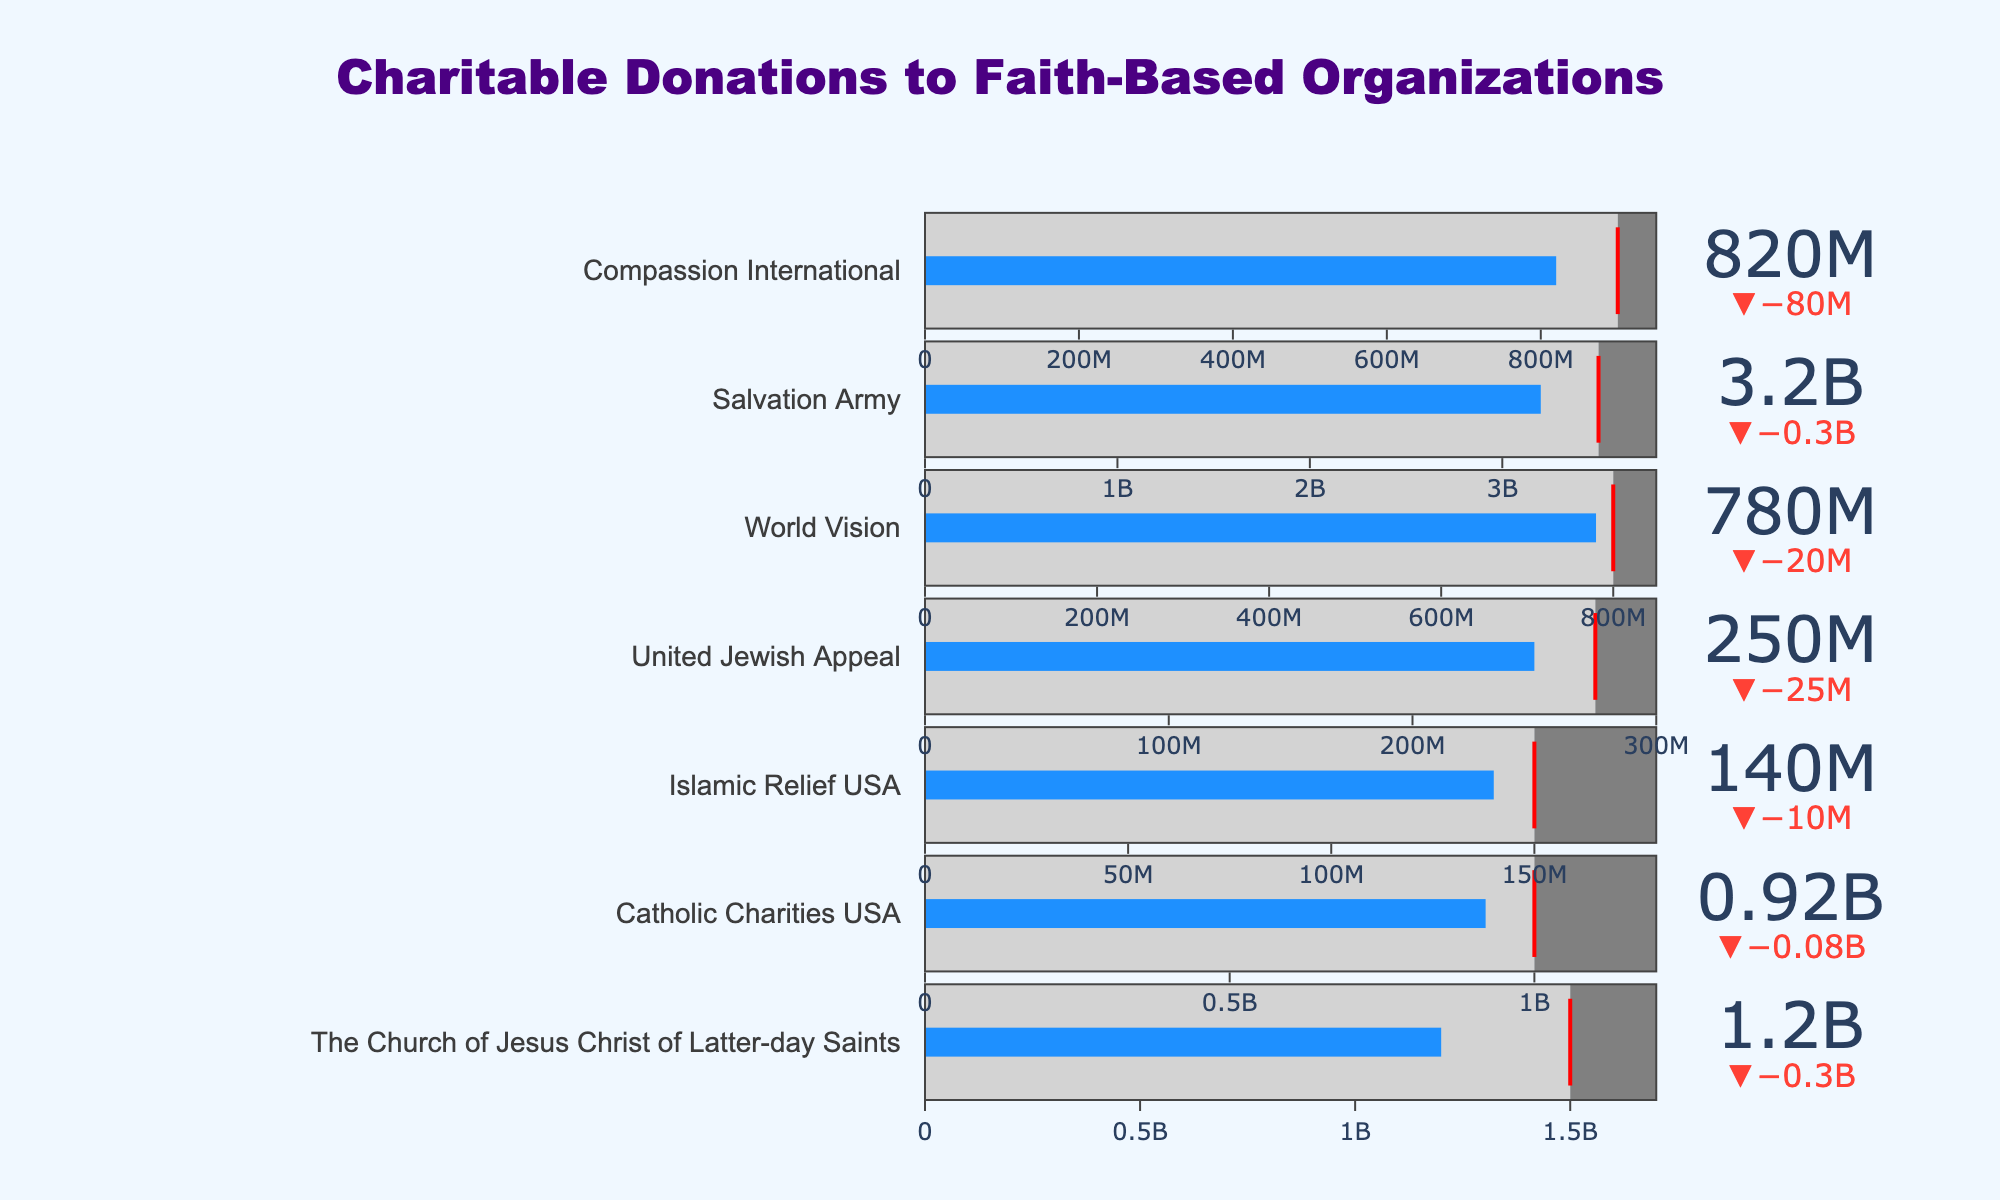What is the highest target donation value among all organizations? Look at the 'Target' values. The Salvation Army has the highest target donation value of 3500000000.
Answer: 3500000000 Which organization received the lowest actual donations? Compare the 'Actual Donations' values. Islamic Relief USA has the lowest actual donations of 140000000.
Answer: Islamic Relief USA How much more did Catholic Charities USA need to meet its target? Subtract the 'Actual Donations' from the 'Target' for Catholic Charities USA: 1000000000 - 920000000 = 80000000.
Answer: 80000000 Which organization exceeded its target by the largest amount? Calculate the difference between 'Actual Donations' and 'Target' for each organization. The Church of Jesus Christ of Latter-day Saints exceeded its target by 1200000000 - 1500000000 = -300000000, Catholic Charities USA by 920000000 - 1000000000 = -80000000, and so on. Then compare these differences, looking for the largest positive value. No organization exceeded its target; all fell short or matched.
Answer: None What is the total actual donation amount for all the organizations combined? Sum the 'Actual Donations' values for all organizations: 1200000000 + 920000000 + 140000000 + 250000000 + 780000000 + 3200000000 + 820000000 = 7310000000.
Answer: 7310000000 Which organization has the smallest gap between actual donations and the comparison value? Subtract the 'Actual Donations' from the 'Comparison' for each organization. The Church of Jesus Christ of Latter-day Saints has a gap of 1700000000 - 1200000000 = 500000000, and so on. The smallest gap is for Catholic Charities USA with 1200000000 - 920000000 = 280000000.
Answer: Catholic Charities USA Is there any organization that met or exceeded its target? Compare 'Actual Donations' with 'Target' for each organization. None of the organizations met or exceeded their targets.
Answer: No What is the average target donation value? Sum the 'Target' values and divide by the number of organizations: (1500000000 + 1000000000 + 150000000 + 275000000 + 800000000 + 3500000000 + 900000000) / 7 = 1092857143.
Answer: 1092857143 Which organization has the highest comparison value, and what is it? Compare the 'Comparison' values. The Salvation Army has the highest comparison value of 3800000000.
Answer: The Salvation Army, 3800000000 